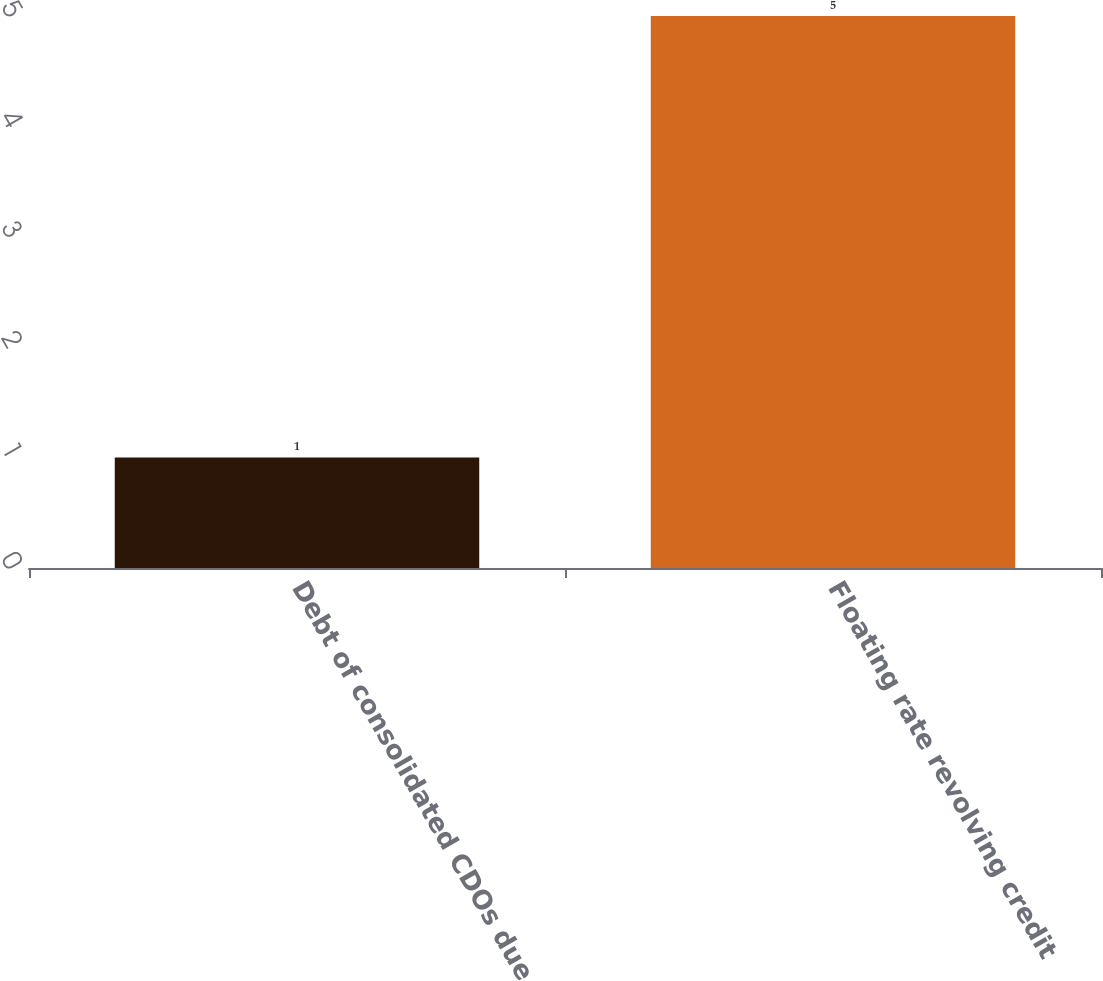Convert chart to OTSL. <chart><loc_0><loc_0><loc_500><loc_500><bar_chart><fcel>Debt of consolidated CDOs due<fcel>Floating rate revolving credit<nl><fcel>1<fcel>5<nl></chart> 